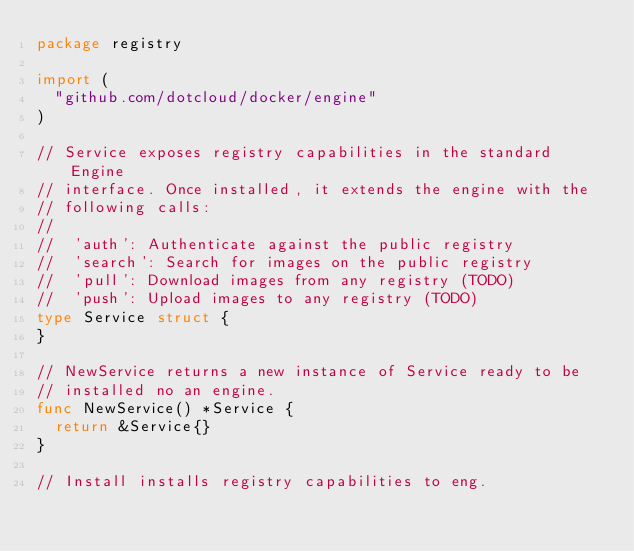<code> <loc_0><loc_0><loc_500><loc_500><_Go_>package registry

import (
	"github.com/dotcloud/docker/engine"
)

// Service exposes registry capabilities in the standard Engine
// interface. Once installed, it extends the engine with the
// following calls:
//
//  'auth': Authenticate against the public registry
//  'search': Search for images on the public registry
//  'pull': Download images from any registry (TODO)
//  'push': Upload images to any registry (TODO)
type Service struct {
}

// NewService returns a new instance of Service ready to be
// installed no an engine.
func NewService() *Service {
	return &Service{}
}

// Install installs registry capabilities to eng.</code> 